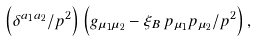Convert formula to latex. <formula><loc_0><loc_0><loc_500><loc_500>\left ( \delta ^ { a _ { 1 } a _ { 2 } } / p ^ { 2 } \right ) \left ( g _ { \mu _ { 1 } \mu _ { 2 } } - \xi _ { B } \, p _ { \mu _ { 1 } } p _ { \mu _ { 2 } } / p ^ { 2 } \right ) ,</formula> 